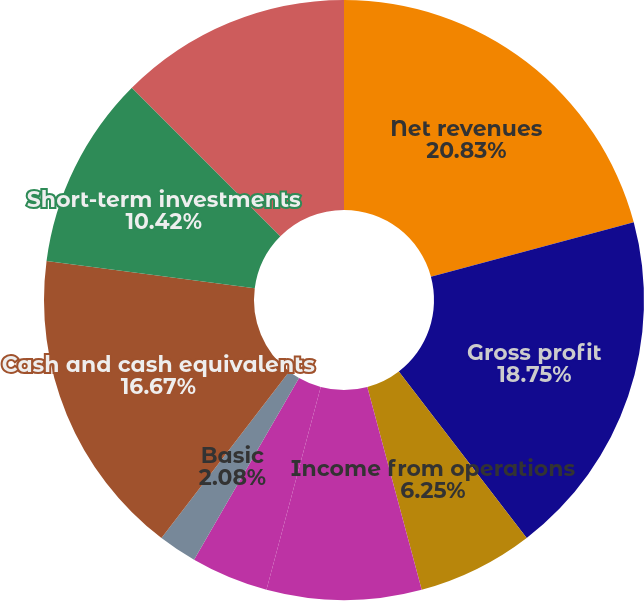Convert chart. <chart><loc_0><loc_0><loc_500><loc_500><pie_chart><fcel>Net revenues<fcel>Gross profit<fcel>Income from operations<fcel>Income from continuing<fcel>Income (loss) from continuing<fcel>Basic<fcel>Diluted<fcel>Cash and cash equivalents<fcel>Short-term investments<fcel>Long-term investments<nl><fcel>20.83%<fcel>18.75%<fcel>6.25%<fcel>8.33%<fcel>4.17%<fcel>2.08%<fcel>0.0%<fcel>16.67%<fcel>10.42%<fcel>12.5%<nl></chart> 